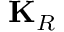Convert formula to latex. <formula><loc_0><loc_0><loc_500><loc_500>K _ { R }</formula> 